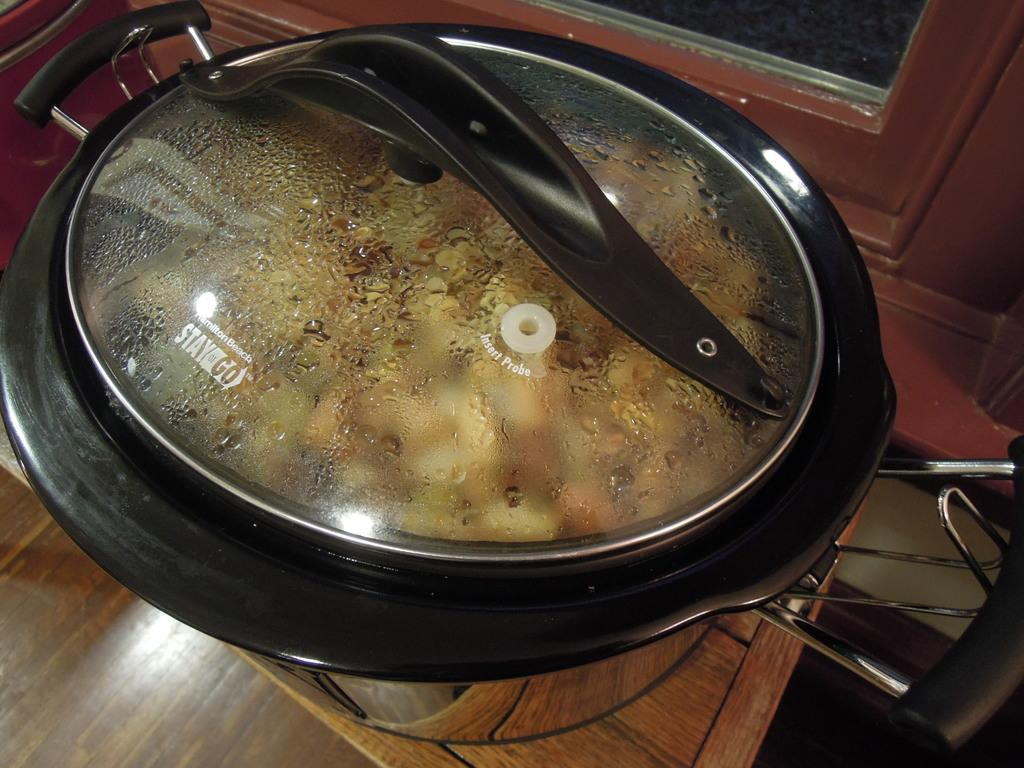What is present in the image? There is a bowl in the image. Where is the bowl located? The bowl is on a wooden platform. What type of yoke is being used by the cattle in the image? There are no cattle or yoke present in the image; it only features a bowl on a wooden platform. 